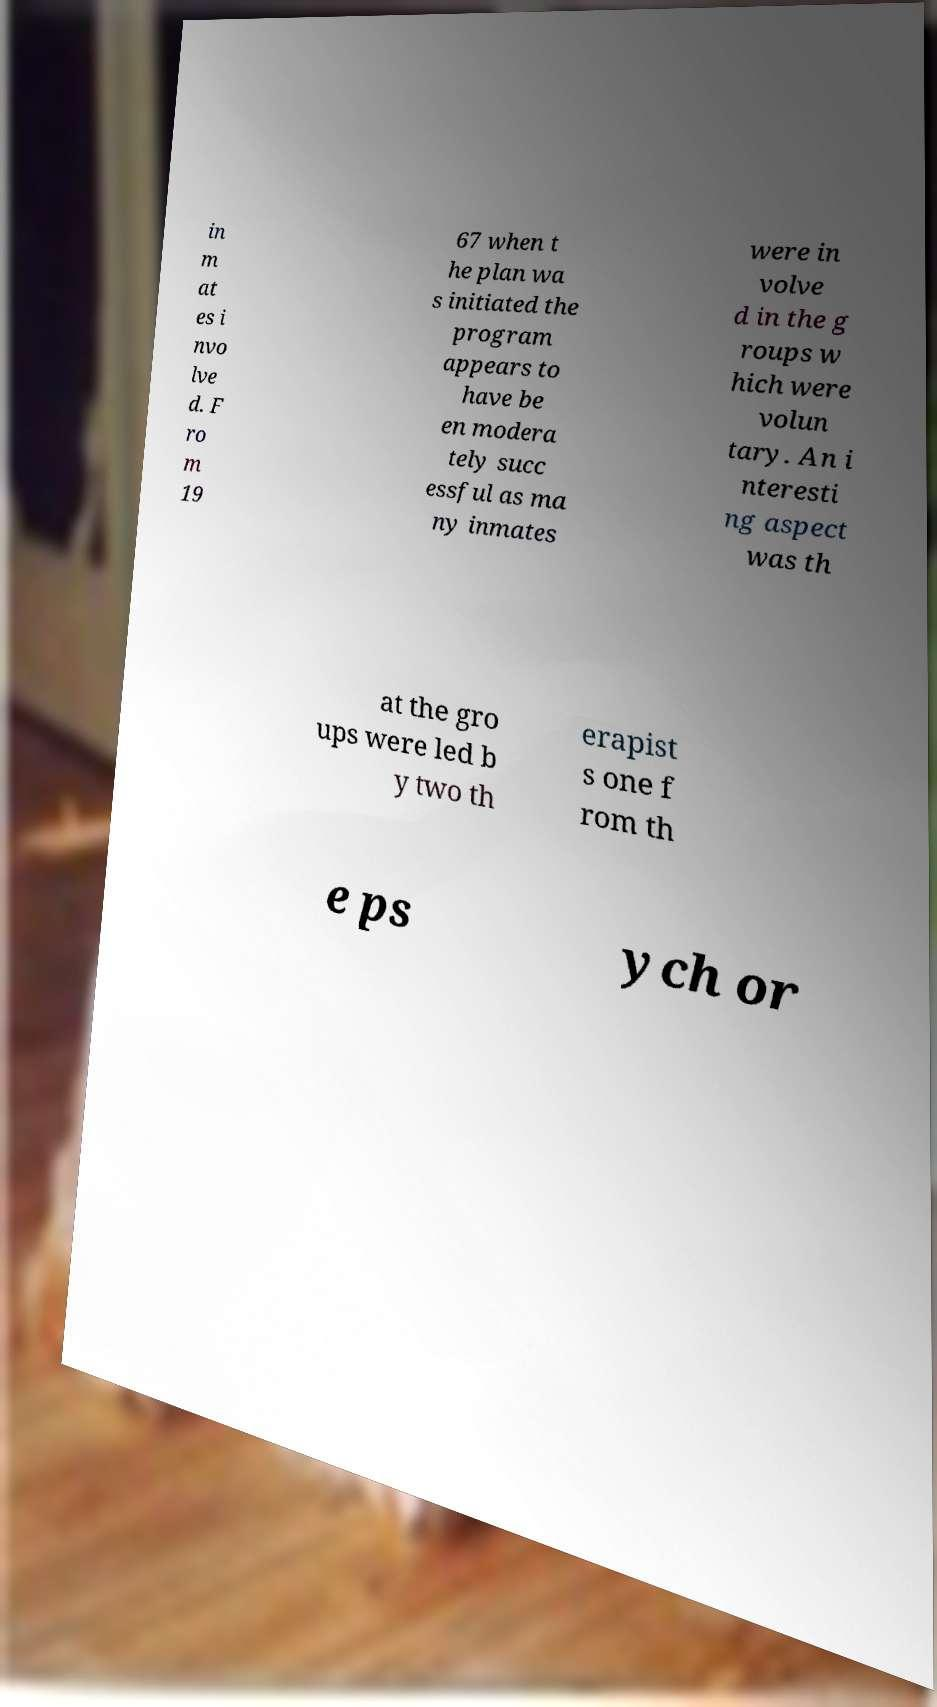Please read and relay the text visible in this image. What does it say? in m at es i nvo lve d. F ro m 19 67 when t he plan wa s initiated the program appears to have be en modera tely succ essful as ma ny inmates were in volve d in the g roups w hich were volun tary. An i nteresti ng aspect was th at the gro ups were led b y two th erapist s one f rom th e ps ych or 